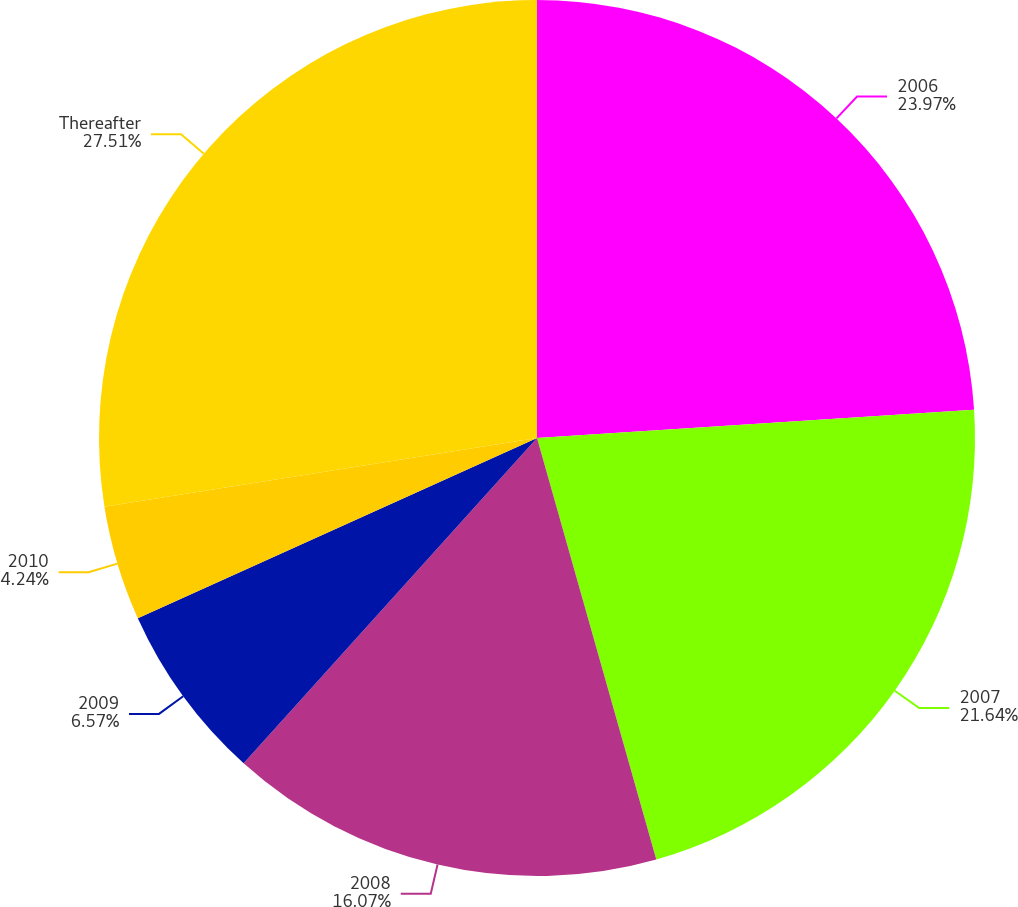Convert chart. <chart><loc_0><loc_0><loc_500><loc_500><pie_chart><fcel>2006<fcel>2007<fcel>2008<fcel>2009<fcel>2010<fcel>Thereafter<nl><fcel>23.97%<fcel>21.64%<fcel>16.07%<fcel>6.57%<fcel>4.24%<fcel>27.51%<nl></chart> 